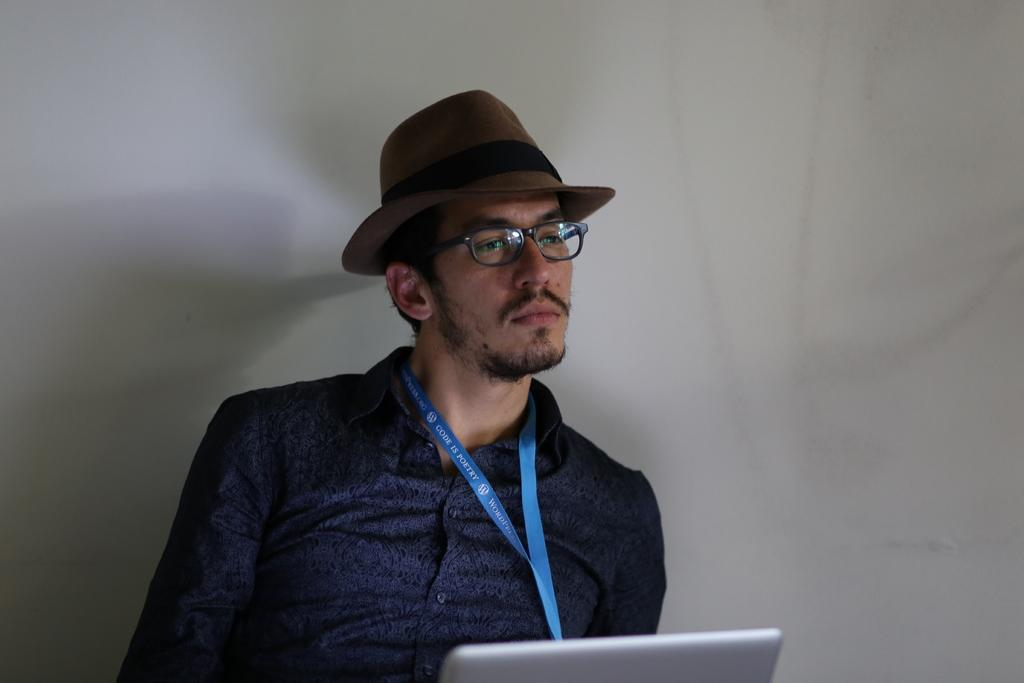Who is present in the image? There is a man in the image. What is the man wearing? The man is wearing clothes, spectacles, and a hat. Does the man have any identification in the image? Yes, the man has an identity card. What else can be seen in the image? There is a device and a wall in the image. How many pears are visible on the wall in the image? There are no pears visible on the wall in the image. What is the size of the man in the image? The size of the man cannot be determined from the image alone, as we do not have a reference point for comparison. 